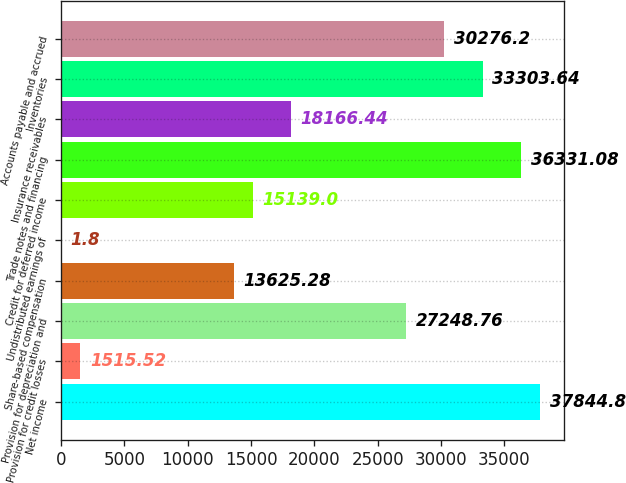Convert chart to OTSL. <chart><loc_0><loc_0><loc_500><loc_500><bar_chart><fcel>Net income<fcel>Provision for credit losses<fcel>Provision for depreciation and<fcel>Share-based compensation<fcel>Undistributed earnings of<fcel>Credit for deferred income<fcel>Trade notes and financing<fcel>Insurance receivables<fcel>Inventories<fcel>Accounts payable and accrued<nl><fcel>37844.8<fcel>1515.52<fcel>27248.8<fcel>13625.3<fcel>1.8<fcel>15139<fcel>36331.1<fcel>18166.4<fcel>33303.6<fcel>30276.2<nl></chart> 